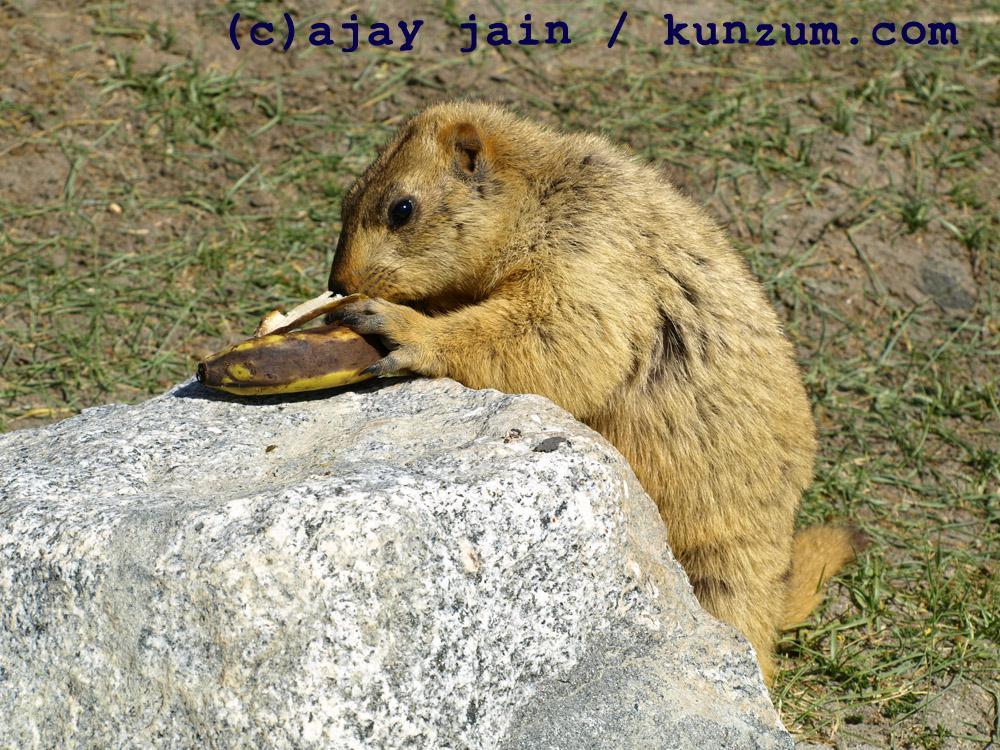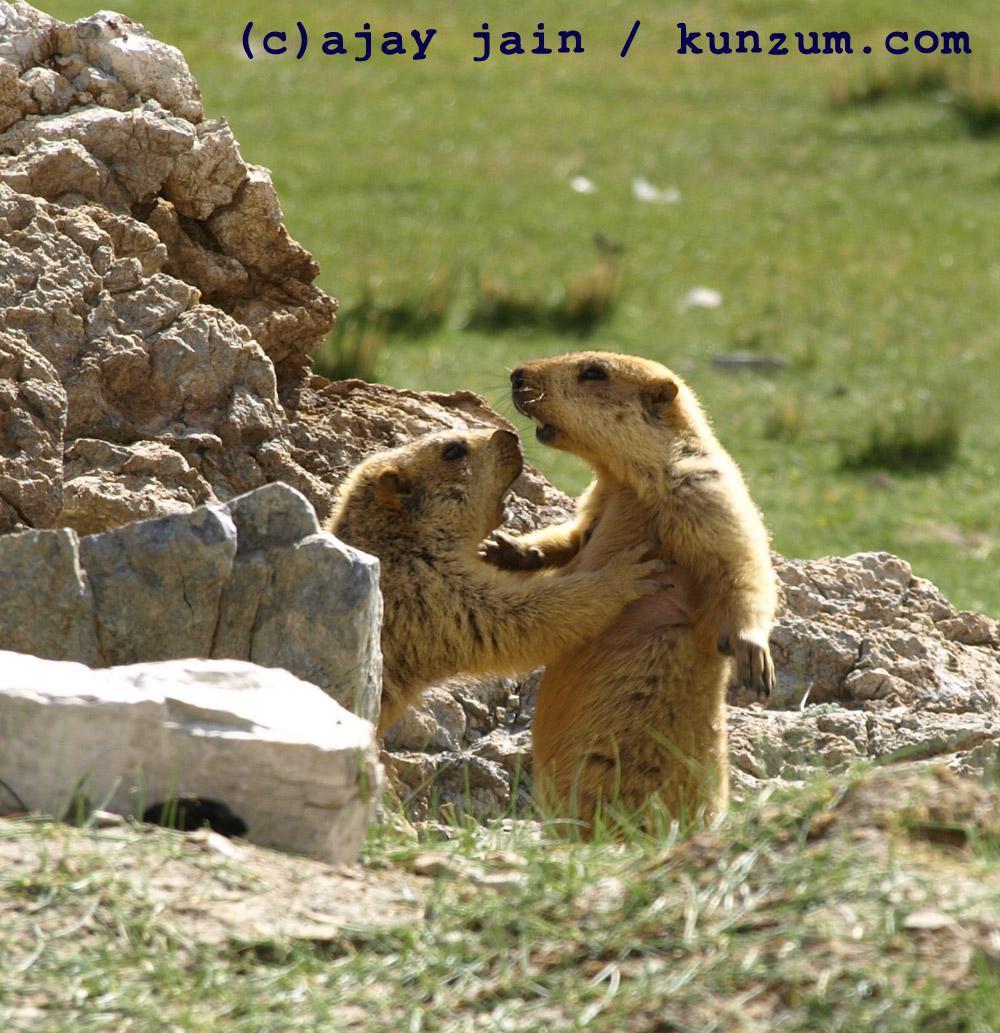The first image is the image on the left, the second image is the image on the right. Considering the images on both sides, is "a single gopher is standing on hind legs with it's arms down" valid? Answer yes or no. No. 